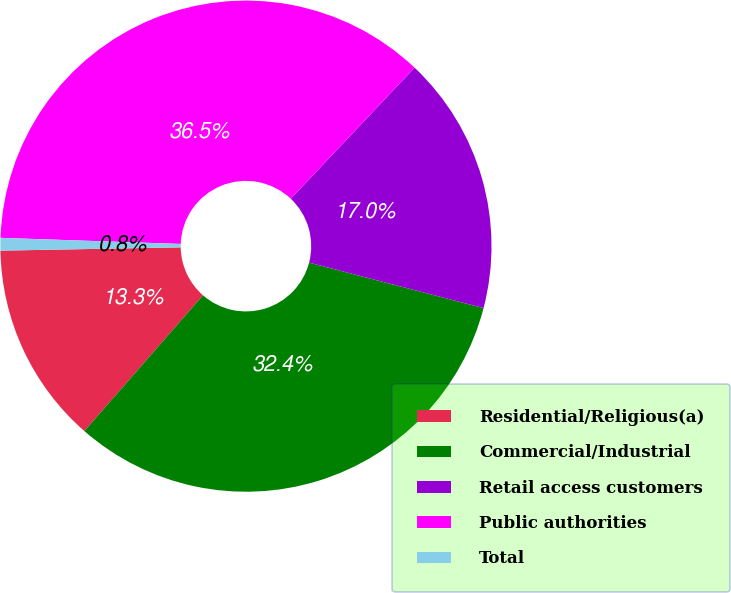Convert chart to OTSL. <chart><loc_0><loc_0><loc_500><loc_500><pie_chart><fcel>Residential/Religious(a)<fcel>Commercial/Industrial<fcel>Retail access customers<fcel>Public authorities<fcel>Total<nl><fcel>13.28%<fcel>32.37%<fcel>17.01%<fcel>36.51%<fcel>0.83%<nl></chart> 